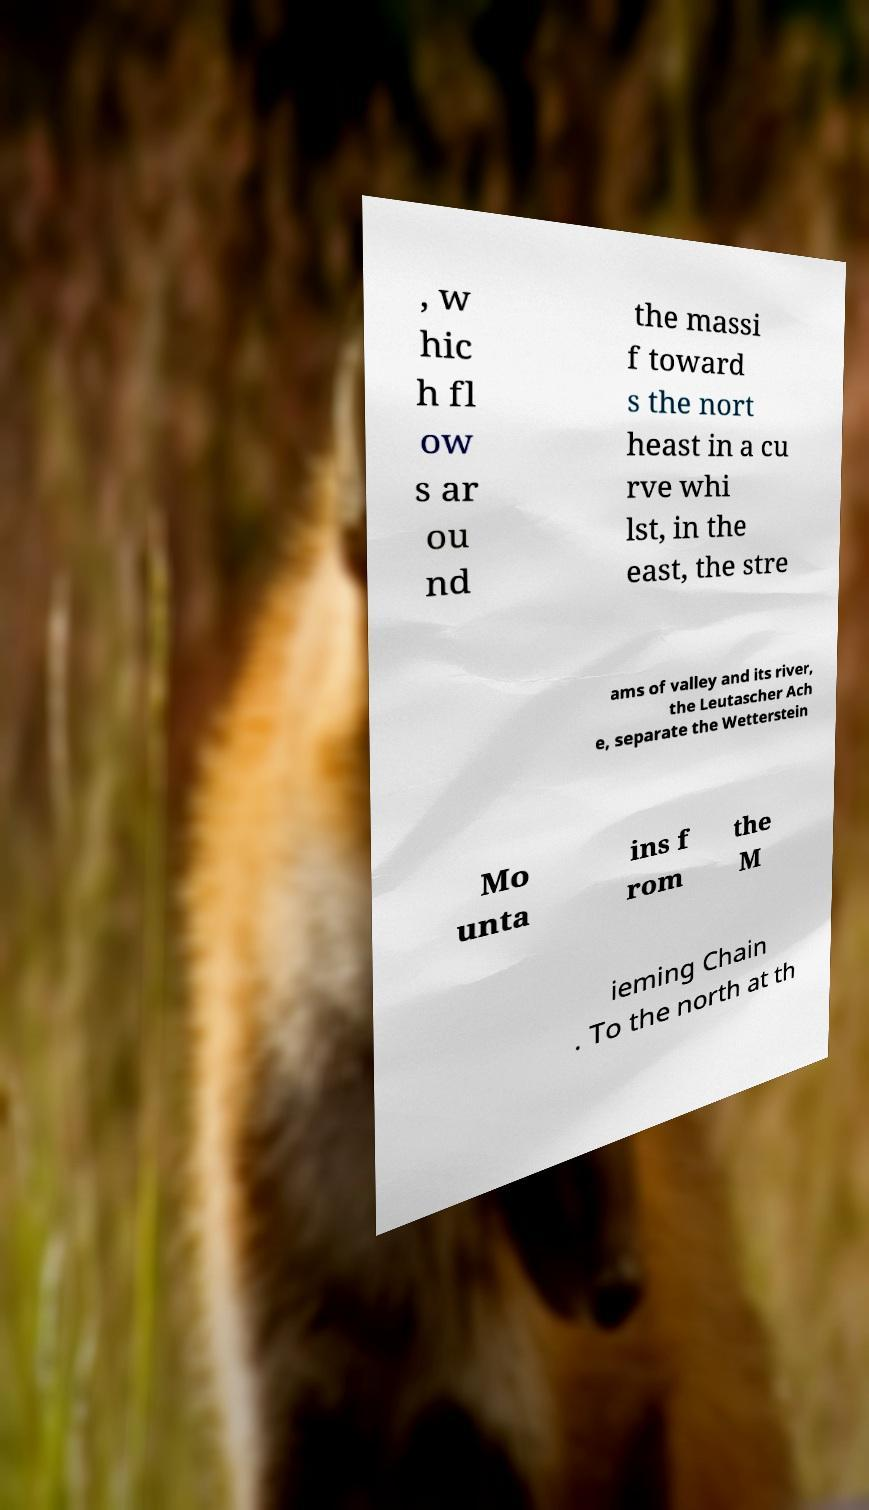For documentation purposes, I need the text within this image transcribed. Could you provide that? , w hic h fl ow s ar ou nd the massi f toward s the nort heast in a cu rve whi lst, in the east, the stre ams of valley and its river, the Leutascher Ach e, separate the Wetterstein Mo unta ins f rom the M ieming Chain . To the north at th 